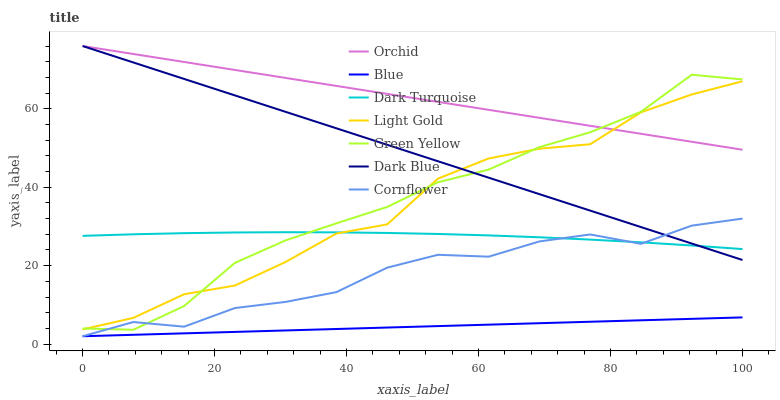Does Cornflower have the minimum area under the curve?
Answer yes or no. No. Does Cornflower have the maximum area under the curve?
Answer yes or no. No. Is Cornflower the smoothest?
Answer yes or no. No. Is Cornflower the roughest?
Answer yes or no. No. Does Dark Turquoise have the lowest value?
Answer yes or no. No. Does Cornflower have the highest value?
Answer yes or no. No. Is Blue less than Dark Turquoise?
Answer yes or no. Yes. Is Dark Blue greater than Blue?
Answer yes or no. Yes. Does Blue intersect Dark Turquoise?
Answer yes or no. No. 